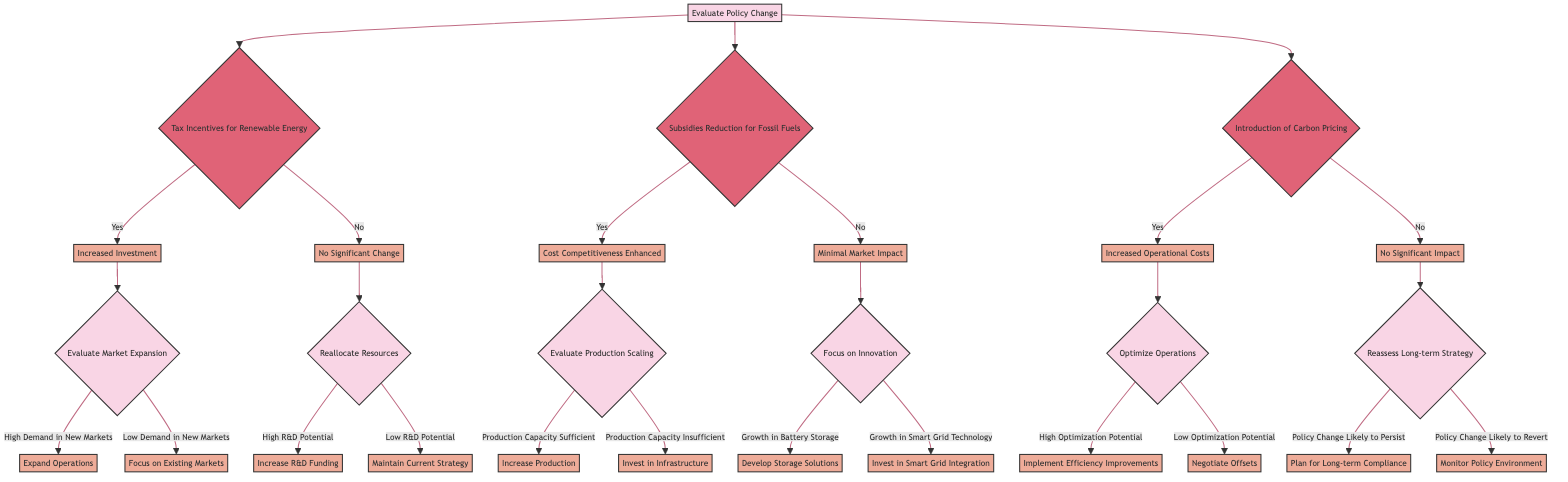What is the root decision in the diagram? The root decision is "Evaluate Policy Change," as indicated at the starting point of the decision tree.
Answer: Evaluate Policy Change How many conditions are under the "Evaluate Policy Change" decision? There are three conditions: "Tax Incentives for Renewable Energy," "Subsidies Reduction for Fossil Fuels," and "Introduction of Carbon Pricing," which branch out from the root decision.
Answer: Three What outcome follows "Tax Incentives for Renewable Energy" if the result is "No Significant Change"? The next decision is "Reallocate Resources," as it leads to evaluating resource allocation only if there is no significant change from the tax incentives.
Answer: Reallocate Resources Which action is taken if "Production Capacity is Insufficient" after "Cost Competitiveness Enhanced"? The outcome for this situation is to "Invest in Infrastructure," as it is the chosen action if the production capacity is insufficient after evaluating production scaling.
Answer: Invest in Infrastructure If "Introduction of Carbon Pricing" results in "Increased Operational Costs," what is the next decision? The next decision would be "Optimize Operations," which is the step taken to handle increased operational costs.
Answer: Optimize Operations What happens if the condition under "Reassess Long-term Strategy" is that the "Policy Change Likely to Persist"? The outcome in this case would be to "Plan for Long-term Compliance," which reflects the strategy in response to a persistent policy change.
Answer: Plan for Long-term Compliance Which outcome leads to focusing on innovation? The outcome "Minimal Market Impact" after evaluating "Subsidies Reduction for Fossil Fuels" leads to this decision, aiming to prioritize innovative solutions in a non-impacted market.
Answer: Focus on Innovation If "High Demand in New Markets" is identified after "Increased Investment," what action should be taken? The action would be to "Expand Operations," indicating a strategy to increase market reach based on high demand detected in new markets.
Answer: Expand Operations What do you need to conclude to maintain the current strategy after reallocating resources? If there is "Low R&D Potential," then the decision will be to maintain the current strategy, reflecting cautious resource management given low innovation prospects.
Answer: Maintain Current Strategy 